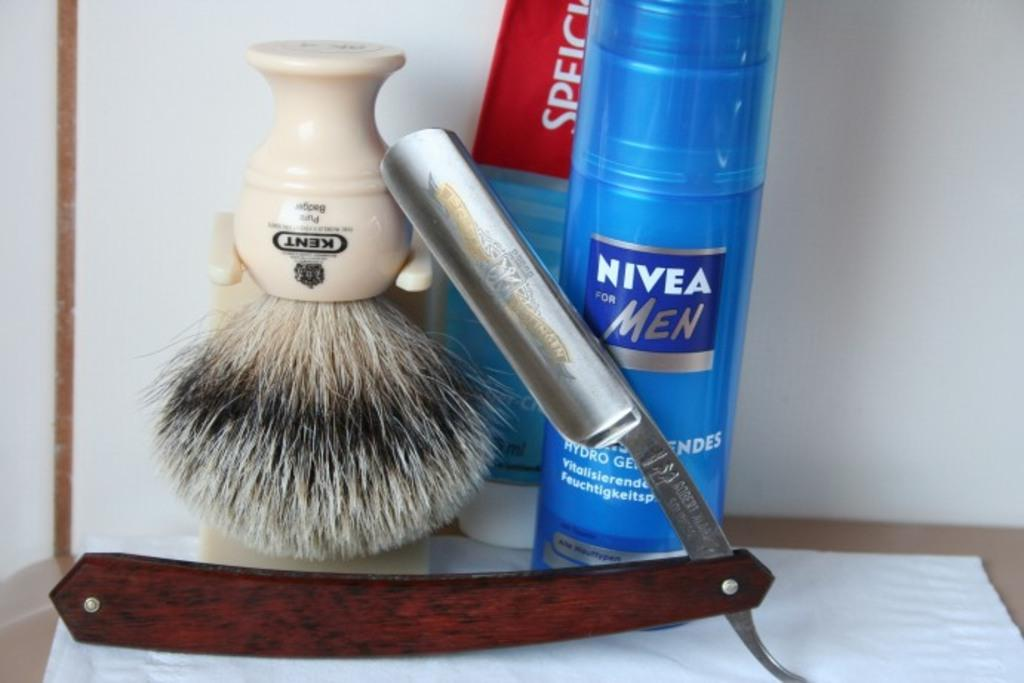<image>
Present a compact description of the photo's key features. a blue bottle that says 'nivea for men' on it by a small brush 